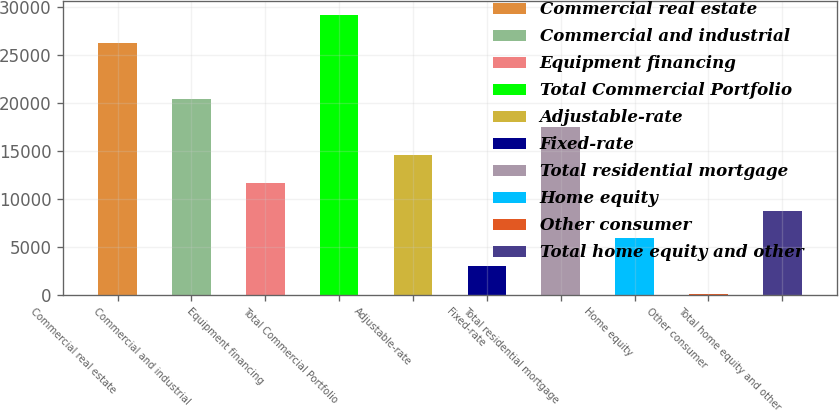<chart> <loc_0><loc_0><loc_500><loc_500><bar_chart><fcel>Commercial real estate<fcel>Commercial and industrial<fcel>Equipment financing<fcel>Total Commercial Portfolio<fcel>Adjustable-rate<fcel>Fixed-rate<fcel>Total residential mortgage<fcel>Home equity<fcel>Other consumer<fcel>Total home equity and other<nl><fcel>26226.2<fcel>20409.3<fcel>11683.9<fcel>29134.7<fcel>14592.4<fcel>2958.47<fcel>17500.8<fcel>5866.94<fcel>50<fcel>8775.41<nl></chart> 